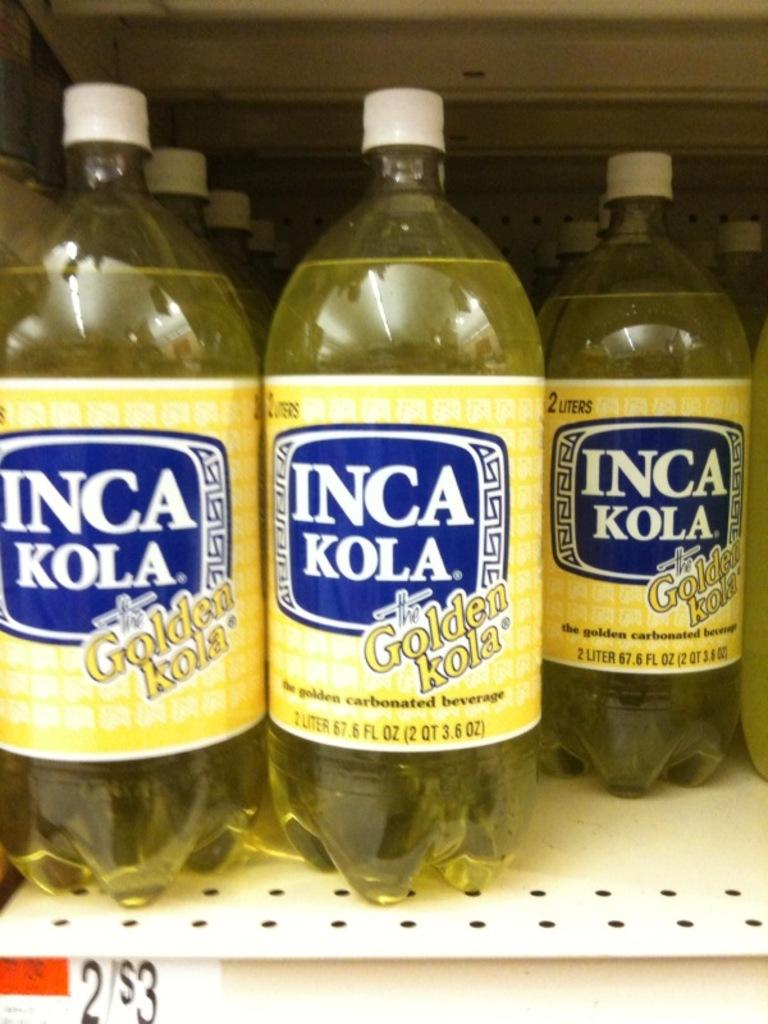Provide a one-sentence caption for the provided image. Bottles of Inca Kola Golden Kola are on a shelf. 